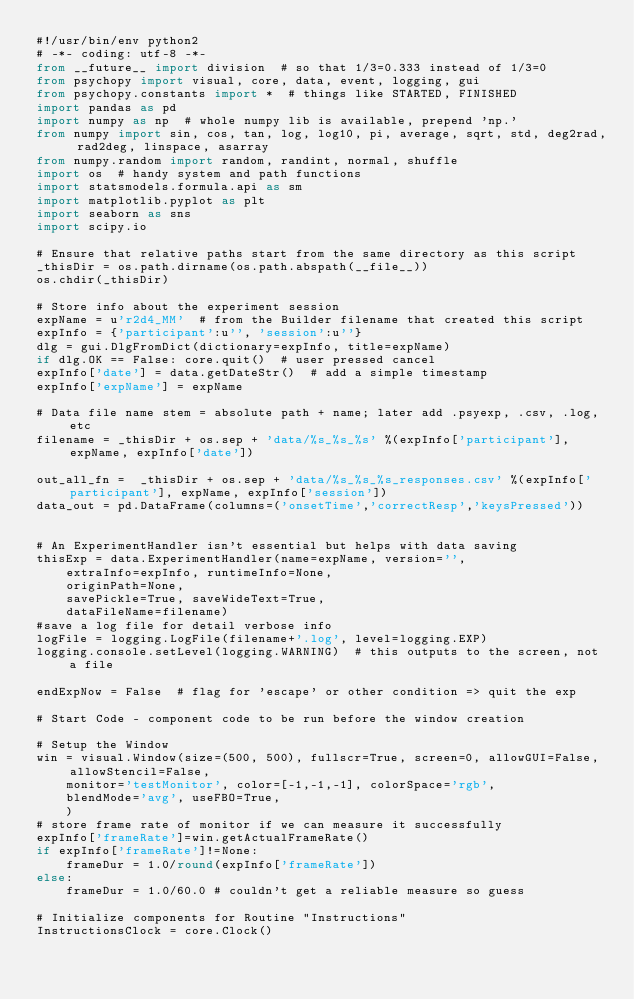Convert code to text. <code><loc_0><loc_0><loc_500><loc_500><_Python_>#!/usr/bin/env python2
# -*- coding: utf-8 -*-
from __future__ import division  # so that 1/3=0.333 instead of 1/3=0
from psychopy import visual, core, data, event, logging, gui
from psychopy.constants import *  # things like STARTED, FINISHED
import pandas as pd
import numpy as np  # whole numpy lib is available, prepend 'np.'
from numpy import sin, cos, tan, log, log10, pi, average, sqrt, std, deg2rad, rad2deg, linspace, asarray
from numpy.random import random, randint, normal, shuffle
import os  # handy system and path functions
import statsmodels.formula.api as sm
import matplotlib.pyplot as plt
import seaborn as sns
import scipy.io

# Ensure that relative paths start from the same directory as this script
_thisDir = os.path.dirname(os.path.abspath(__file__))
os.chdir(_thisDir)

# Store info about the experiment session
expName = u'r2d4_MM'  # from the Builder filename that created this script
expInfo = {'participant':u'', 'session':u''}
dlg = gui.DlgFromDict(dictionary=expInfo, title=expName)
if dlg.OK == False: core.quit()  # user pressed cancel
expInfo['date'] = data.getDateStr()  # add a simple timestamp
expInfo['expName'] = expName

# Data file name stem = absolute path + name; later add .psyexp, .csv, .log, etc
filename = _thisDir + os.sep + 'data/%s_%s_%s' %(expInfo['participant'], expName, expInfo['date'])

out_all_fn =  _thisDir + os.sep + 'data/%s_%s_%s_responses.csv' %(expInfo['participant'], expName, expInfo['session'])
data_out = pd.DataFrame(columns=('onsetTime','correctResp','keysPressed'))


# An ExperimentHandler isn't essential but helps with data saving
thisExp = data.ExperimentHandler(name=expName, version='',
    extraInfo=expInfo, runtimeInfo=None,
    originPath=None,
    savePickle=True, saveWideText=True,
    dataFileName=filename)
#save a log file for detail verbose info
logFile = logging.LogFile(filename+'.log', level=logging.EXP)
logging.console.setLevel(logging.WARNING)  # this outputs to the screen, not a file

endExpNow = False  # flag for 'escape' or other condition => quit the exp

# Start Code - component code to be run before the window creation

# Setup the Window
win = visual.Window(size=(500, 500), fullscr=True, screen=0, allowGUI=False, allowStencil=False,
    monitor='testMonitor', color=[-1,-1,-1], colorSpace='rgb',
    blendMode='avg', useFBO=True,
    )
# store frame rate of monitor if we can measure it successfully
expInfo['frameRate']=win.getActualFrameRate()
if expInfo['frameRate']!=None:
    frameDur = 1.0/round(expInfo['frameRate'])
else:
    frameDur = 1.0/60.0 # couldn't get a reliable measure so guess

# Initialize components for Routine "Instructions"
InstructionsClock = core.Clock()</code> 